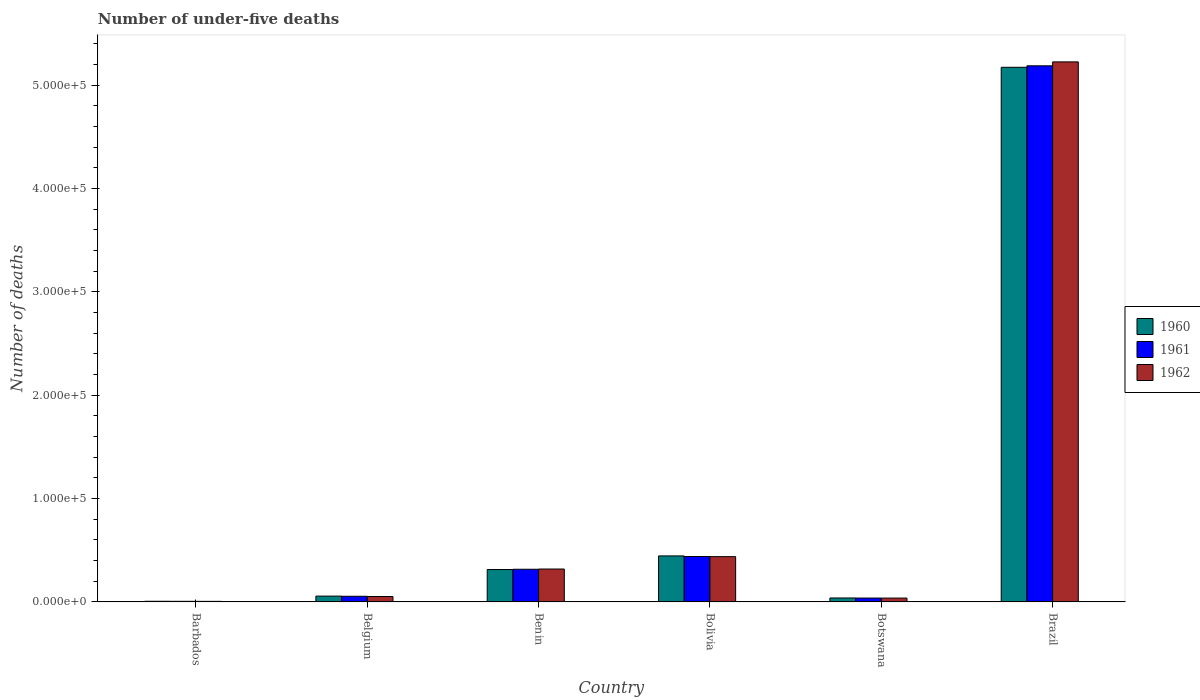How many groups of bars are there?
Offer a very short reply. 6. How many bars are there on the 6th tick from the left?
Offer a terse response. 3. What is the label of the 6th group of bars from the left?
Offer a very short reply. Brazil. What is the number of under-five deaths in 1960 in Botswana?
Offer a very short reply. 3811. Across all countries, what is the maximum number of under-five deaths in 1960?
Provide a succinct answer. 5.17e+05. Across all countries, what is the minimum number of under-five deaths in 1960?
Your answer should be compact. 615. In which country was the number of under-five deaths in 1962 maximum?
Your response must be concise. Brazil. In which country was the number of under-five deaths in 1960 minimum?
Make the answer very short. Barbados. What is the total number of under-five deaths in 1961 in the graph?
Offer a terse response. 6.04e+05. What is the difference between the number of under-five deaths in 1962 in Barbados and that in Bolivia?
Your answer should be very brief. -4.33e+04. What is the difference between the number of under-five deaths in 1960 in Bolivia and the number of under-five deaths in 1961 in Benin?
Provide a short and direct response. 1.29e+04. What is the average number of under-five deaths in 1961 per country?
Your answer should be very brief. 1.01e+05. What is the difference between the number of under-five deaths of/in 1960 and number of under-five deaths of/in 1961 in Belgium?
Offer a terse response. 153. In how many countries, is the number of under-five deaths in 1960 greater than 120000?
Keep it short and to the point. 1. What is the ratio of the number of under-five deaths in 1962 in Belgium to that in Bolivia?
Offer a terse response. 0.12. What is the difference between the highest and the second highest number of under-five deaths in 1960?
Your answer should be compact. -4.73e+05. What is the difference between the highest and the lowest number of under-five deaths in 1960?
Your answer should be compact. 5.17e+05. Is it the case that in every country, the sum of the number of under-five deaths in 1962 and number of under-five deaths in 1960 is greater than the number of under-five deaths in 1961?
Your answer should be compact. Yes. How many countries are there in the graph?
Provide a short and direct response. 6. How many legend labels are there?
Your answer should be compact. 3. What is the title of the graph?
Provide a short and direct response. Number of under-five deaths. What is the label or title of the X-axis?
Keep it short and to the point. Country. What is the label or title of the Y-axis?
Offer a very short reply. Number of deaths. What is the Number of deaths in 1960 in Barbados?
Your response must be concise. 615. What is the Number of deaths in 1961 in Barbados?
Ensure brevity in your answer.  574. What is the Number of deaths in 1962 in Barbados?
Make the answer very short. 536. What is the Number of deaths in 1960 in Belgium?
Keep it short and to the point. 5614. What is the Number of deaths in 1961 in Belgium?
Give a very brief answer. 5461. What is the Number of deaths in 1962 in Belgium?
Make the answer very short. 5229. What is the Number of deaths in 1960 in Benin?
Ensure brevity in your answer.  3.13e+04. What is the Number of deaths of 1961 in Benin?
Your answer should be compact. 3.16e+04. What is the Number of deaths of 1962 in Benin?
Your answer should be very brief. 3.18e+04. What is the Number of deaths in 1960 in Bolivia?
Make the answer very short. 4.45e+04. What is the Number of deaths of 1961 in Bolivia?
Your answer should be compact. 4.39e+04. What is the Number of deaths in 1962 in Bolivia?
Give a very brief answer. 4.38e+04. What is the Number of deaths of 1960 in Botswana?
Offer a terse response. 3811. What is the Number of deaths of 1961 in Botswana?
Make the answer very short. 3727. What is the Number of deaths of 1962 in Botswana?
Your response must be concise. 3708. What is the Number of deaths of 1960 in Brazil?
Ensure brevity in your answer.  5.17e+05. What is the Number of deaths in 1961 in Brazil?
Offer a terse response. 5.19e+05. What is the Number of deaths of 1962 in Brazil?
Ensure brevity in your answer.  5.23e+05. Across all countries, what is the maximum Number of deaths in 1960?
Offer a very short reply. 5.17e+05. Across all countries, what is the maximum Number of deaths in 1961?
Your answer should be very brief. 5.19e+05. Across all countries, what is the maximum Number of deaths of 1962?
Your answer should be very brief. 5.23e+05. Across all countries, what is the minimum Number of deaths in 1960?
Offer a very short reply. 615. Across all countries, what is the minimum Number of deaths in 1961?
Provide a short and direct response. 574. Across all countries, what is the minimum Number of deaths of 1962?
Your answer should be very brief. 536. What is the total Number of deaths of 1960 in the graph?
Provide a short and direct response. 6.03e+05. What is the total Number of deaths in 1961 in the graph?
Offer a terse response. 6.04e+05. What is the total Number of deaths in 1962 in the graph?
Offer a terse response. 6.08e+05. What is the difference between the Number of deaths in 1960 in Barbados and that in Belgium?
Your answer should be compact. -4999. What is the difference between the Number of deaths of 1961 in Barbados and that in Belgium?
Your answer should be very brief. -4887. What is the difference between the Number of deaths of 1962 in Barbados and that in Belgium?
Keep it short and to the point. -4693. What is the difference between the Number of deaths of 1960 in Barbados and that in Benin?
Your answer should be very brief. -3.07e+04. What is the difference between the Number of deaths in 1961 in Barbados and that in Benin?
Provide a succinct answer. -3.10e+04. What is the difference between the Number of deaths of 1962 in Barbados and that in Benin?
Your answer should be compact. -3.13e+04. What is the difference between the Number of deaths of 1960 in Barbados and that in Bolivia?
Provide a succinct answer. -4.39e+04. What is the difference between the Number of deaths in 1961 in Barbados and that in Bolivia?
Your answer should be very brief. -4.34e+04. What is the difference between the Number of deaths in 1962 in Barbados and that in Bolivia?
Provide a short and direct response. -4.33e+04. What is the difference between the Number of deaths of 1960 in Barbados and that in Botswana?
Make the answer very short. -3196. What is the difference between the Number of deaths of 1961 in Barbados and that in Botswana?
Offer a very short reply. -3153. What is the difference between the Number of deaths in 1962 in Barbados and that in Botswana?
Offer a very short reply. -3172. What is the difference between the Number of deaths in 1960 in Barbados and that in Brazil?
Offer a terse response. -5.17e+05. What is the difference between the Number of deaths in 1961 in Barbados and that in Brazil?
Your answer should be very brief. -5.18e+05. What is the difference between the Number of deaths in 1962 in Barbados and that in Brazil?
Keep it short and to the point. -5.22e+05. What is the difference between the Number of deaths in 1960 in Belgium and that in Benin?
Offer a very short reply. -2.57e+04. What is the difference between the Number of deaths of 1961 in Belgium and that in Benin?
Offer a very short reply. -2.61e+04. What is the difference between the Number of deaths of 1962 in Belgium and that in Benin?
Provide a succinct answer. -2.66e+04. What is the difference between the Number of deaths in 1960 in Belgium and that in Bolivia?
Ensure brevity in your answer.  -3.89e+04. What is the difference between the Number of deaths of 1961 in Belgium and that in Bolivia?
Give a very brief answer. -3.85e+04. What is the difference between the Number of deaths of 1962 in Belgium and that in Bolivia?
Your answer should be compact. -3.86e+04. What is the difference between the Number of deaths of 1960 in Belgium and that in Botswana?
Your response must be concise. 1803. What is the difference between the Number of deaths of 1961 in Belgium and that in Botswana?
Offer a very short reply. 1734. What is the difference between the Number of deaths of 1962 in Belgium and that in Botswana?
Provide a succinct answer. 1521. What is the difference between the Number of deaths of 1960 in Belgium and that in Brazil?
Give a very brief answer. -5.12e+05. What is the difference between the Number of deaths of 1961 in Belgium and that in Brazil?
Provide a short and direct response. -5.13e+05. What is the difference between the Number of deaths of 1962 in Belgium and that in Brazil?
Make the answer very short. -5.17e+05. What is the difference between the Number of deaths of 1960 in Benin and that in Bolivia?
Give a very brief answer. -1.32e+04. What is the difference between the Number of deaths of 1961 in Benin and that in Bolivia?
Give a very brief answer. -1.23e+04. What is the difference between the Number of deaths in 1962 in Benin and that in Bolivia?
Keep it short and to the point. -1.20e+04. What is the difference between the Number of deaths in 1960 in Benin and that in Botswana?
Your response must be concise. 2.75e+04. What is the difference between the Number of deaths in 1961 in Benin and that in Botswana?
Offer a terse response. 2.79e+04. What is the difference between the Number of deaths in 1962 in Benin and that in Botswana?
Keep it short and to the point. 2.81e+04. What is the difference between the Number of deaths of 1960 in Benin and that in Brazil?
Ensure brevity in your answer.  -4.86e+05. What is the difference between the Number of deaths in 1961 in Benin and that in Brazil?
Offer a terse response. -4.87e+05. What is the difference between the Number of deaths of 1962 in Benin and that in Brazil?
Offer a very short reply. -4.91e+05. What is the difference between the Number of deaths in 1960 in Bolivia and that in Botswana?
Give a very brief answer. 4.07e+04. What is the difference between the Number of deaths in 1961 in Bolivia and that in Botswana?
Make the answer very short. 4.02e+04. What is the difference between the Number of deaths in 1962 in Bolivia and that in Botswana?
Your answer should be compact. 4.01e+04. What is the difference between the Number of deaths in 1960 in Bolivia and that in Brazil?
Provide a short and direct response. -4.73e+05. What is the difference between the Number of deaths in 1961 in Bolivia and that in Brazil?
Provide a succinct answer. -4.75e+05. What is the difference between the Number of deaths in 1962 in Bolivia and that in Brazil?
Give a very brief answer. -4.79e+05. What is the difference between the Number of deaths of 1960 in Botswana and that in Brazil?
Your answer should be very brief. -5.14e+05. What is the difference between the Number of deaths of 1961 in Botswana and that in Brazil?
Your response must be concise. -5.15e+05. What is the difference between the Number of deaths in 1962 in Botswana and that in Brazil?
Give a very brief answer. -5.19e+05. What is the difference between the Number of deaths in 1960 in Barbados and the Number of deaths in 1961 in Belgium?
Provide a succinct answer. -4846. What is the difference between the Number of deaths of 1960 in Barbados and the Number of deaths of 1962 in Belgium?
Provide a succinct answer. -4614. What is the difference between the Number of deaths in 1961 in Barbados and the Number of deaths in 1962 in Belgium?
Make the answer very short. -4655. What is the difference between the Number of deaths of 1960 in Barbados and the Number of deaths of 1961 in Benin?
Make the answer very short. -3.10e+04. What is the difference between the Number of deaths of 1960 in Barbados and the Number of deaths of 1962 in Benin?
Provide a short and direct response. -3.12e+04. What is the difference between the Number of deaths in 1961 in Barbados and the Number of deaths in 1962 in Benin?
Provide a succinct answer. -3.13e+04. What is the difference between the Number of deaths of 1960 in Barbados and the Number of deaths of 1961 in Bolivia?
Provide a short and direct response. -4.33e+04. What is the difference between the Number of deaths of 1960 in Barbados and the Number of deaths of 1962 in Bolivia?
Your response must be concise. -4.32e+04. What is the difference between the Number of deaths of 1961 in Barbados and the Number of deaths of 1962 in Bolivia?
Offer a very short reply. -4.32e+04. What is the difference between the Number of deaths in 1960 in Barbados and the Number of deaths in 1961 in Botswana?
Keep it short and to the point. -3112. What is the difference between the Number of deaths of 1960 in Barbados and the Number of deaths of 1962 in Botswana?
Keep it short and to the point. -3093. What is the difference between the Number of deaths in 1961 in Barbados and the Number of deaths in 1962 in Botswana?
Your answer should be very brief. -3134. What is the difference between the Number of deaths of 1960 in Barbados and the Number of deaths of 1961 in Brazil?
Provide a short and direct response. -5.18e+05. What is the difference between the Number of deaths of 1960 in Barbados and the Number of deaths of 1962 in Brazil?
Offer a terse response. -5.22e+05. What is the difference between the Number of deaths in 1961 in Barbados and the Number of deaths in 1962 in Brazil?
Provide a short and direct response. -5.22e+05. What is the difference between the Number of deaths in 1960 in Belgium and the Number of deaths in 1961 in Benin?
Provide a short and direct response. -2.60e+04. What is the difference between the Number of deaths in 1960 in Belgium and the Number of deaths in 1962 in Benin?
Your answer should be very brief. -2.62e+04. What is the difference between the Number of deaths in 1961 in Belgium and the Number of deaths in 1962 in Benin?
Keep it short and to the point. -2.64e+04. What is the difference between the Number of deaths of 1960 in Belgium and the Number of deaths of 1961 in Bolivia?
Your answer should be very brief. -3.83e+04. What is the difference between the Number of deaths of 1960 in Belgium and the Number of deaths of 1962 in Bolivia?
Give a very brief answer. -3.82e+04. What is the difference between the Number of deaths in 1961 in Belgium and the Number of deaths in 1962 in Bolivia?
Offer a terse response. -3.83e+04. What is the difference between the Number of deaths of 1960 in Belgium and the Number of deaths of 1961 in Botswana?
Offer a very short reply. 1887. What is the difference between the Number of deaths of 1960 in Belgium and the Number of deaths of 1962 in Botswana?
Your answer should be compact. 1906. What is the difference between the Number of deaths in 1961 in Belgium and the Number of deaths in 1962 in Botswana?
Make the answer very short. 1753. What is the difference between the Number of deaths in 1960 in Belgium and the Number of deaths in 1961 in Brazil?
Your response must be concise. -5.13e+05. What is the difference between the Number of deaths of 1960 in Belgium and the Number of deaths of 1962 in Brazil?
Ensure brevity in your answer.  -5.17e+05. What is the difference between the Number of deaths in 1961 in Belgium and the Number of deaths in 1962 in Brazil?
Offer a very short reply. -5.17e+05. What is the difference between the Number of deaths in 1960 in Benin and the Number of deaths in 1961 in Bolivia?
Make the answer very short. -1.26e+04. What is the difference between the Number of deaths of 1960 in Benin and the Number of deaths of 1962 in Bolivia?
Ensure brevity in your answer.  -1.25e+04. What is the difference between the Number of deaths in 1961 in Benin and the Number of deaths in 1962 in Bolivia?
Your response must be concise. -1.22e+04. What is the difference between the Number of deaths in 1960 in Benin and the Number of deaths in 1961 in Botswana?
Your answer should be compact. 2.76e+04. What is the difference between the Number of deaths of 1960 in Benin and the Number of deaths of 1962 in Botswana?
Provide a succinct answer. 2.76e+04. What is the difference between the Number of deaths in 1961 in Benin and the Number of deaths in 1962 in Botswana?
Offer a very short reply. 2.79e+04. What is the difference between the Number of deaths in 1960 in Benin and the Number of deaths in 1961 in Brazil?
Your answer should be very brief. -4.87e+05. What is the difference between the Number of deaths of 1960 in Benin and the Number of deaths of 1962 in Brazil?
Offer a very short reply. -4.91e+05. What is the difference between the Number of deaths of 1961 in Benin and the Number of deaths of 1962 in Brazil?
Provide a short and direct response. -4.91e+05. What is the difference between the Number of deaths of 1960 in Bolivia and the Number of deaths of 1961 in Botswana?
Your response must be concise. 4.08e+04. What is the difference between the Number of deaths in 1960 in Bolivia and the Number of deaths in 1962 in Botswana?
Provide a short and direct response. 4.08e+04. What is the difference between the Number of deaths in 1961 in Bolivia and the Number of deaths in 1962 in Botswana?
Offer a terse response. 4.02e+04. What is the difference between the Number of deaths in 1960 in Bolivia and the Number of deaths in 1961 in Brazil?
Your answer should be very brief. -4.74e+05. What is the difference between the Number of deaths of 1960 in Bolivia and the Number of deaths of 1962 in Brazil?
Make the answer very short. -4.78e+05. What is the difference between the Number of deaths in 1961 in Bolivia and the Number of deaths in 1962 in Brazil?
Make the answer very short. -4.79e+05. What is the difference between the Number of deaths of 1960 in Botswana and the Number of deaths of 1961 in Brazil?
Offer a very short reply. -5.15e+05. What is the difference between the Number of deaths of 1960 in Botswana and the Number of deaths of 1962 in Brazil?
Provide a short and direct response. -5.19e+05. What is the difference between the Number of deaths of 1961 in Botswana and the Number of deaths of 1962 in Brazil?
Provide a short and direct response. -5.19e+05. What is the average Number of deaths in 1960 per country?
Give a very brief answer. 1.01e+05. What is the average Number of deaths of 1961 per country?
Your answer should be compact. 1.01e+05. What is the average Number of deaths in 1962 per country?
Your response must be concise. 1.01e+05. What is the difference between the Number of deaths of 1960 and Number of deaths of 1961 in Barbados?
Provide a succinct answer. 41. What is the difference between the Number of deaths of 1960 and Number of deaths of 1962 in Barbados?
Provide a short and direct response. 79. What is the difference between the Number of deaths of 1961 and Number of deaths of 1962 in Barbados?
Your answer should be very brief. 38. What is the difference between the Number of deaths in 1960 and Number of deaths in 1961 in Belgium?
Make the answer very short. 153. What is the difference between the Number of deaths in 1960 and Number of deaths in 1962 in Belgium?
Ensure brevity in your answer.  385. What is the difference between the Number of deaths in 1961 and Number of deaths in 1962 in Belgium?
Your response must be concise. 232. What is the difference between the Number of deaths of 1960 and Number of deaths of 1961 in Benin?
Make the answer very short. -252. What is the difference between the Number of deaths of 1960 and Number of deaths of 1962 in Benin?
Offer a very short reply. -477. What is the difference between the Number of deaths of 1961 and Number of deaths of 1962 in Benin?
Your answer should be very brief. -225. What is the difference between the Number of deaths of 1960 and Number of deaths of 1961 in Bolivia?
Offer a very short reply. 571. What is the difference between the Number of deaths of 1960 and Number of deaths of 1962 in Bolivia?
Your answer should be very brief. 704. What is the difference between the Number of deaths in 1961 and Number of deaths in 1962 in Bolivia?
Offer a terse response. 133. What is the difference between the Number of deaths of 1960 and Number of deaths of 1962 in Botswana?
Ensure brevity in your answer.  103. What is the difference between the Number of deaths of 1960 and Number of deaths of 1961 in Brazil?
Provide a succinct answer. -1424. What is the difference between the Number of deaths of 1960 and Number of deaths of 1962 in Brazil?
Give a very brief answer. -5233. What is the difference between the Number of deaths of 1961 and Number of deaths of 1962 in Brazil?
Your response must be concise. -3809. What is the ratio of the Number of deaths in 1960 in Barbados to that in Belgium?
Provide a short and direct response. 0.11. What is the ratio of the Number of deaths of 1961 in Barbados to that in Belgium?
Your response must be concise. 0.11. What is the ratio of the Number of deaths of 1962 in Barbados to that in Belgium?
Your answer should be compact. 0.1. What is the ratio of the Number of deaths of 1960 in Barbados to that in Benin?
Keep it short and to the point. 0.02. What is the ratio of the Number of deaths of 1961 in Barbados to that in Benin?
Make the answer very short. 0.02. What is the ratio of the Number of deaths in 1962 in Barbados to that in Benin?
Ensure brevity in your answer.  0.02. What is the ratio of the Number of deaths of 1960 in Barbados to that in Bolivia?
Give a very brief answer. 0.01. What is the ratio of the Number of deaths of 1961 in Barbados to that in Bolivia?
Your answer should be compact. 0.01. What is the ratio of the Number of deaths of 1962 in Barbados to that in Bolivia?
Ensure brevity in your answer.  0.01. What is the ratio of the Number of deaths of 1960 in Barbados to that in Botswana?
Provide a short and direct response. 0.16. What is the ratio of the Number of deaths in 1961 in Barbados to that in Botswana?
Offer a very short reply. 0.15. What is the ratio of the Number of deaths in 1962 in Barbados to that in Botswana?
Give a very brief answer. 0.14. What is the ratio of the Number of deaths of 1960 in Barbados to that in Brazil?
Provide a succinct answer. 0. What is the ratio of the Number of deaths of 1961 in Barbados to that in Brazil?
Give a very brief answer. 0. What is the ratio of the Number of deaths in 1960 in Belgium to that in Benin?
Your answer should be compact. 0.18. What is the ratio of the Number of deaths in 1961 in Belgium to that in Benin?
Your answer should be very brief. 0.17. What is the ratio of the Number of deaths in 1962 in Belgium to that in Benin?
Your response must be concise. 0.16. What is the ratio of the Number of deaths of 1960 in Belgium to that in Bolivia?
Offer a terse response. 0.13. What is the ratio of the Number of deaths of 1961 in Belgium to that in Bolivia?
Ensure brevity in your answer.  0.12. What is the ratio of the Number of deaths of 1962 in Belgium to that in Bolivia?
Offer a terse response. 0.12. What is the ratio of the Number of deaths of 1960 in Belgium to that in Botswana?
Your answer should be compact. 1.47. What is the ratio of the Number of deaths of 1961 in Belgium to that in Botswana?
Provide a short and direct response. 1.47. What is the ratio of the Number of deaths in 1962 in Belgium to that in Botswana?
Ensure brevity in your answer.  1.41. What is the ratio of the Number of deaths in 1960 in Belgium to that in Brazil?
Your answer should be very brief. 0.01. What is the ratio of the Number of deaths in 1961 in Belgium to that in Brazil?
Provide a succinct answer. 0.01. What is the ratio of the Number of deaths in 1960 in Benin to that in Bolivia?
Provide a succinct answer. 0.7. What is the ratio of the Number of deaths in 1961 in Benin to that in Bolivia?
Give a very brief answer. 0.72. What is the ratio of the Number of deaths in 1962 in Benin to that in Bolivia?
Keep it short and to the point. 0.73. What is the ratio of the Number of deaths of 1960 in Benin to that in Botswana?
Provide a short and direct response. 8.23. What is the ratio of the Number of deaths of 1961 in Benin to that in Botswana?
Keep it short and to the point. 8.48. What is the ratio of the Number of deaths of 1962 in Benin to that in Botswana?
Your response must be concise. 8.58. What is the ratio of the Number of deaths in 1960 in Benin to that in Brazil?
Offer a terse response. 0.06. What is the ratio of the Number of deaths in 1961 in Benin to that in Brazil?
Provide a succinct answer. 0.06. What is the ratio of the Number of deaths in 1962 in Benin to that in Brazil?
Your answer should be compact. 0.06. What is the ratio of the Number of deaths in 1960 in Bolivia to that in Botswana?
Offer a very short reply. 11.68. What is the ratio of the Number of deaths in 1961 in Bolivia to that in Botswana?
Offer a very short reply. 11.79. What is the ratio of the Number of deaths in 1962 in Bolivia to that in Botswana?
Keep it short and to the point. 11.81. What is the ratio of the Number of deaths of 1960 in Bolivia to that in Brazil?
Your response must be concise. 0.09. What is the ratio of the Number of deaths in 1961 in Bolivia to that in Brazil?
Give a very brief answer. 0.08. What is the ratio of the Number of deaths in 1962 in Bolivia to that in Brazil?
Your answer should be compact. 0.08. What is the ratio of the Number of deaths in 1960 in Botswana to that in Brazil?
Your answer should be compact. 0.01. What is the ratio of the Number of deaths in 1961 in Botswana to that in Brazil?
Offer a very short reply. 0.01. What is the ratio of the Number of deaths of 1962 in Botswana to that in Brazil?
Your answer should be very brief. 0.01. What is the difference between the highest and the second highest Number of deaths of 1960?
Provide a succinct answer. 4.73e+05. What is the difference between the highest and the second highest Number of deaths of 1961?
Provide a succinct answer. 4.75e+05. What is the difference between the highest and the second highest Number of deaths of 1962?
Your answer should be compact. 4.79e+05. What is the difference between the highest and the lowest Number of deaths of 1960?
Give a very brief answer. 5.17e+05. What is the difference between the highest and the lowest Number of deaths of 1961?
Your answer should be compact. 5.18e+05. What is the difference between the highest and the lowest Number of deaths of 1962?
Keep it short and to the point. 5.22e+05. 